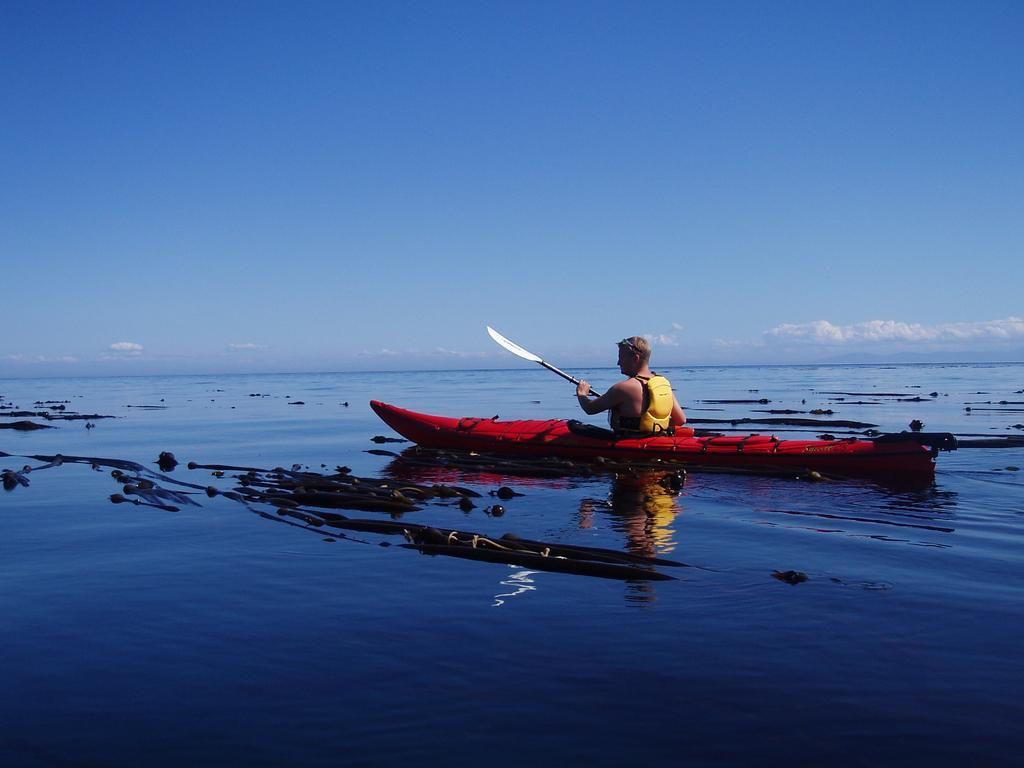How would you summarize this image in a sentence or two? This picture is clicked outside the city. In the center there is a person riding a red color sailboat and we can see there are some items in the water body. In the background there is a sky. 